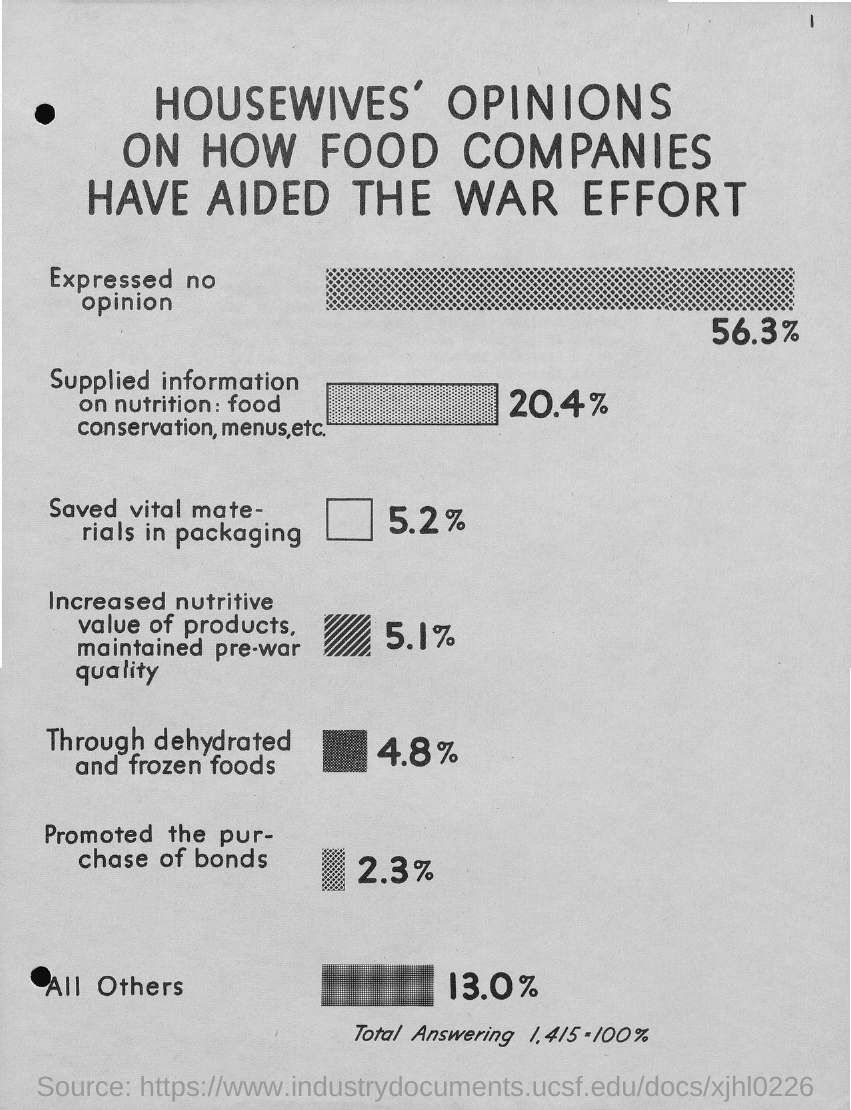Outline some significant characteristics in this image. According to the survey, 56.3% of housewives did not express an opinion. 